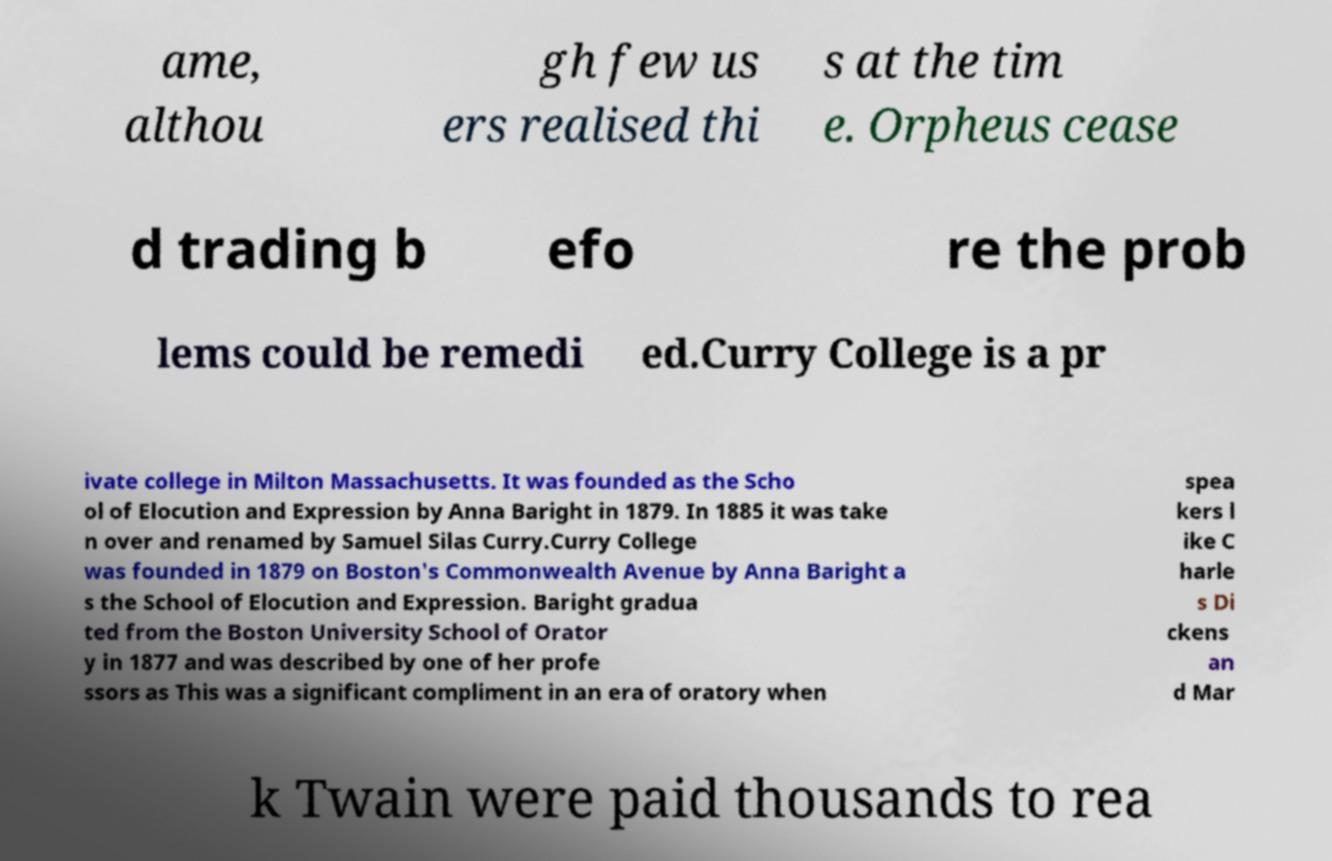There's text embedded in this image that I need extracted. Can you transcribe it verbatim? ame, althou gh few us ers realised thi s at the tim e. Orpheus cease d trading b efo re the prob lems could be remedi ed.Curry College is a pr ivate college in Milton Massachusetts. It was founded as the Scho ol of Elocution and Expression by Anna Baright in 1879. In 1885 it was take n over and renamed by Samuel Silas Curry.Curry College was founded in 1879 on Boston's Commonwealth Avenue by Anna Baright a s the School of Elocution and Expression. Baright gradua ted from the Boston University School of Orator y in 1877 and was described by one of her profe ssors as This was a significant compliment in an era of oratory when spea kers l ike C harle s Di ckens an d Mar k Twain were paid thousands to rea 